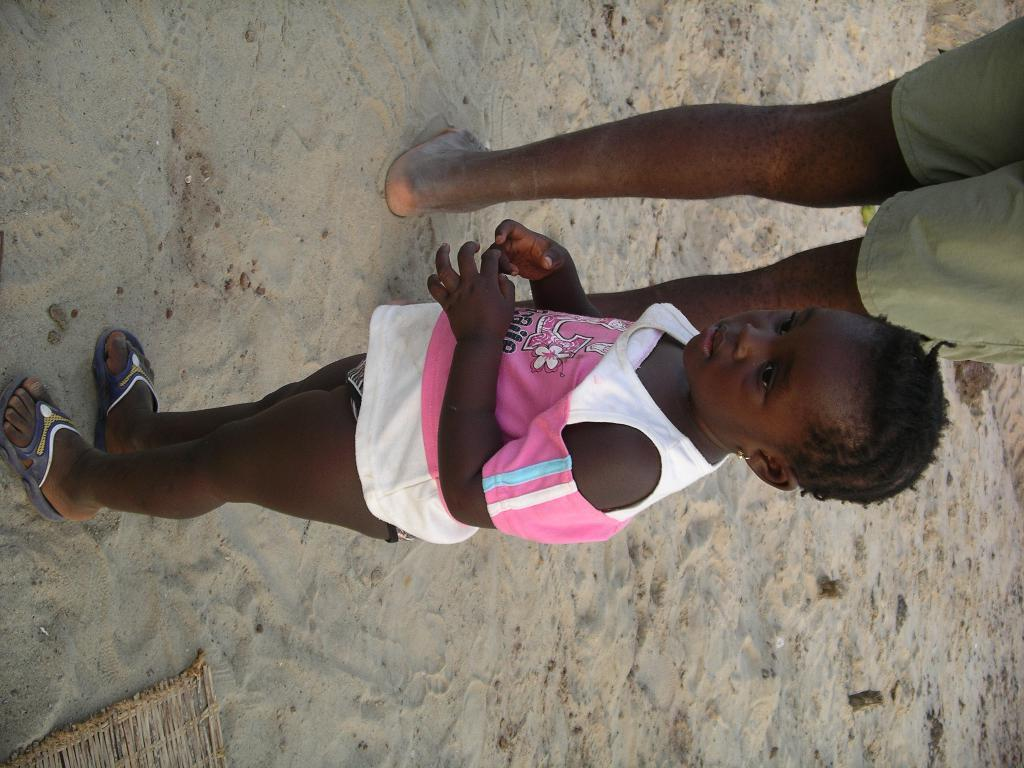What is the main subject of the image? There is a child in the image. What is the child wearing? The child is wearing a white and pink dress. Where is the child standing? The child is standing on the sand. Can you identify any other person in the image? Yes, there is a person in the image. What method is the child using to measure the sand in the image? There is no indication in the image that the child is measuring the sand, so it cannot be determined from the picture. 